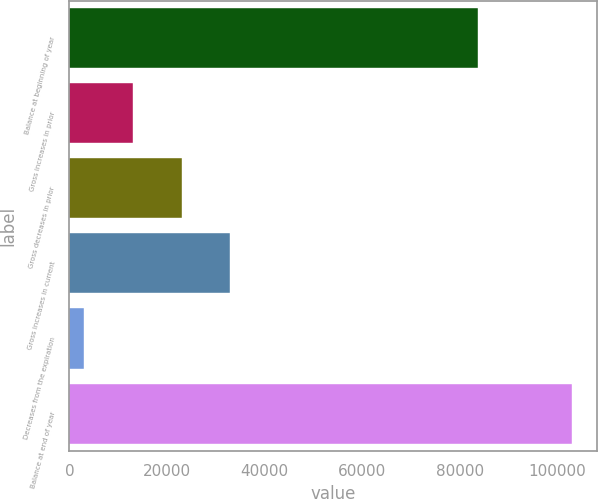<chart> <loc_0><loc_0><loc_500><loc_500><bar_chart><fcel>Balance at beginning of year<fcel>Gross increases in prior<fcel>Gross decreases in prior<fcel>Gross increases in current<fcel>Decreases from the expiration<fcel>Balance at end of year<nl><fcel>83814<fcel>12995.9<fcel>23003.8<fcel>33011.7<fcel>2988<fcel>103067<nl></chart> 